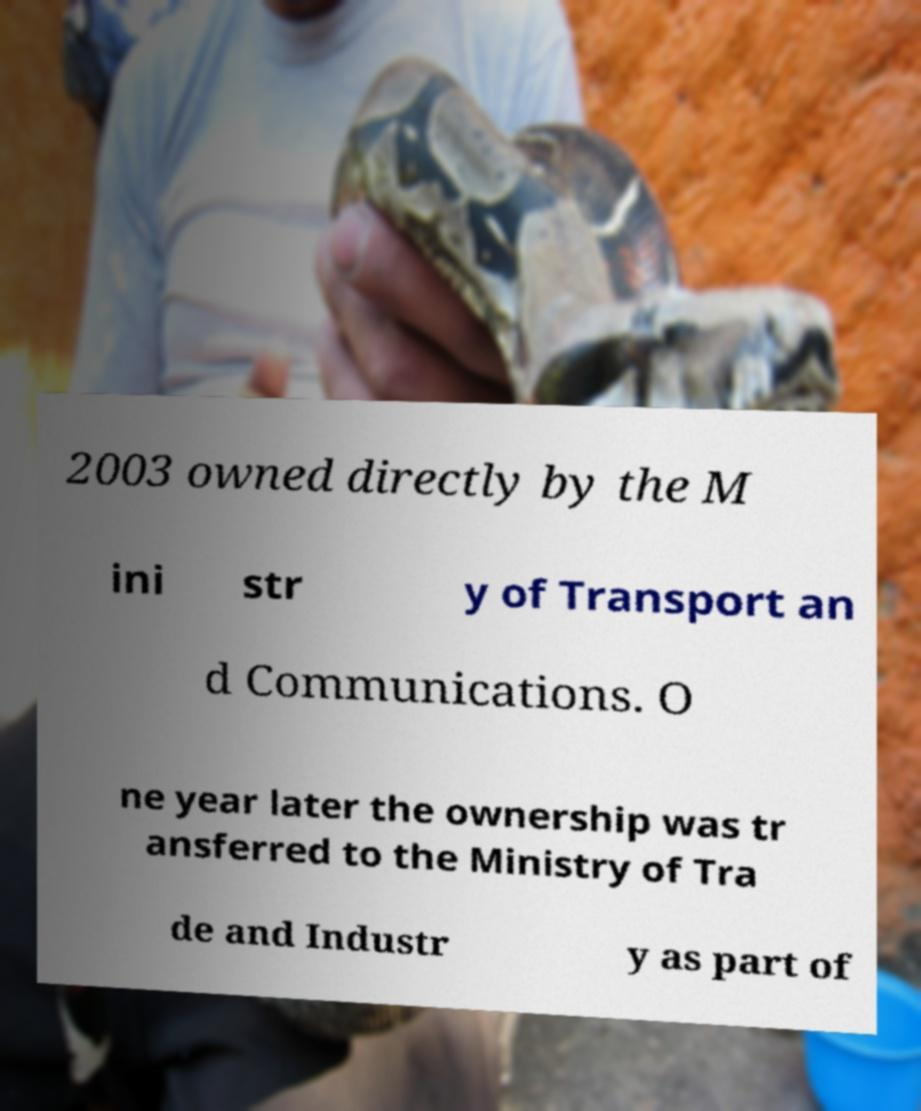What messages or text are displayed in this image? I need them in a readable, typed format. 2003 owned directly by the M ini str y of Transport an d Communications. O ne year later the ownership was tr ansferred to the Ministry of Tra de and Industr y as part of 